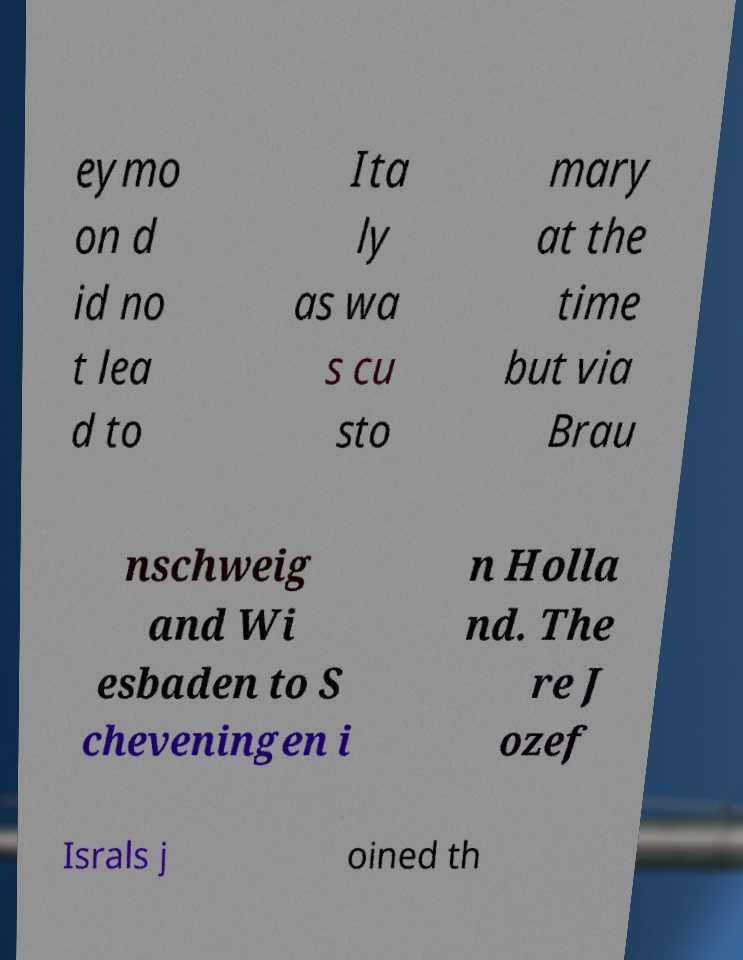Can you read and provide the text displayed in the image?This photo seems to have some interesting text. Can you extract and type it out for me? eymo on d id no t lea d to Ita ly as wa s cu sto mary at the time but via Brau nschweig and Wi esbaden to S cheveningen i n Holla nd. The re J ozef Israls j oined th 